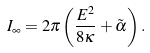Convert formula to latex. <formula><loc_0><loc_0><loc_500><loc_500>I _ { \infty } = 2 \pi \left ( \frac { E ^ { 2 } } { 8 \kappa } + \tilde { \alpha } \right ) .</formula> 